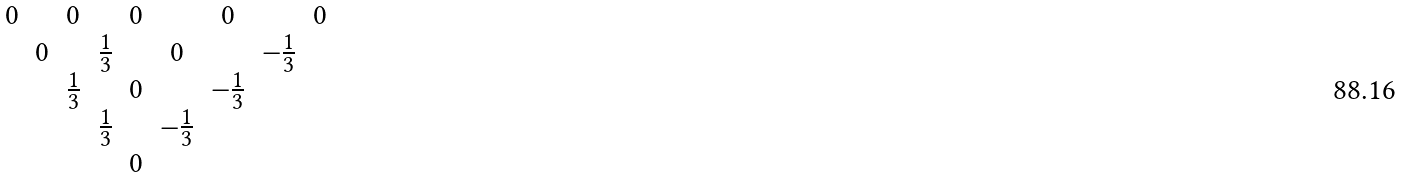<formula> <loc_0><loc_0><loc_500><loc_500>\begin{matrix} 0 & & 0 & & 0 & & 0 & & 0 \\ & 0 & & \frac { 1 } { 3 } & & 0 & & - \frac { 1 } { 3 } & \\ & & \frac { 1 } { 3 } & & 0 & & - \frac { 1 } { 3 } & & \\ & & & \frac { 1 } { 3 } & & - \frac { 1 } { 3 } & & & \\ & & & & 0 & & & & \end{matrix}</formula> 